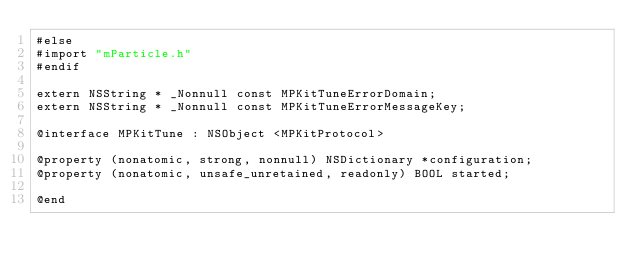<code> <loc_0><loc_0><loc_500><loc_500><_C_>#else
#import "mParticle.h"
#endif

extern NSString * _Nonnull const MPKitTuneErrorDomain;
extern NSString * _Nonnull const MPKitTuneErrorMessageKey;

@interface MPKitTune : NSObject <MPKitProtocol>

@property (nonatomic, strong, nonnull) NSDictionary *configuration;
@property (nonatomic, unsafe_unretained, readonly) BOOL started;

@end
</code> 